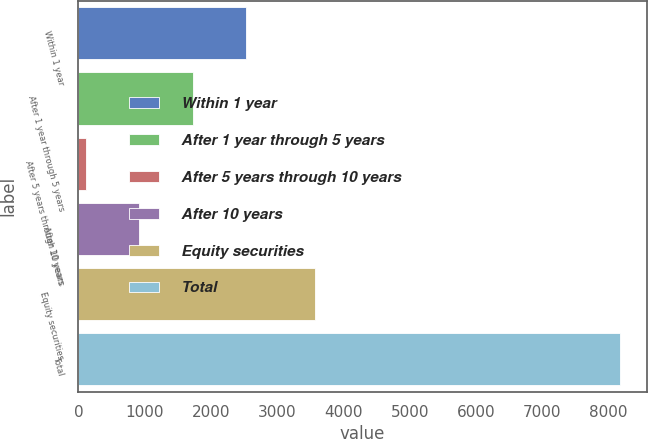<chart> <loc_0><loc_0><loc_500><loc_500><bar_chart><fcel>Within 1 year<fcel>After 1 year through 5 years<fcel>After 5 years through 10 years<fcel>After 10 years<fcel>Equity securities<fcel>Total<nl><fcel>2527.5<fcel>1722<fcel>111<fcel>916.5<fcel>3573<fcel>8166<nl></chart> 